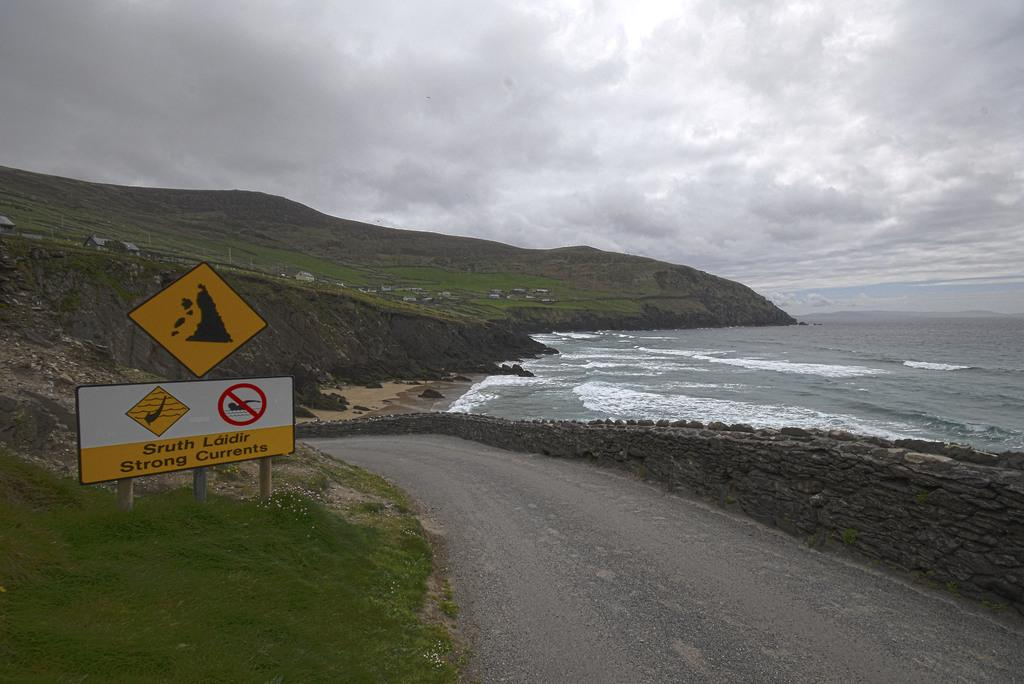Provide a one-sentence caption for the provided image. A warning sign on a beach advises of strong currents. 